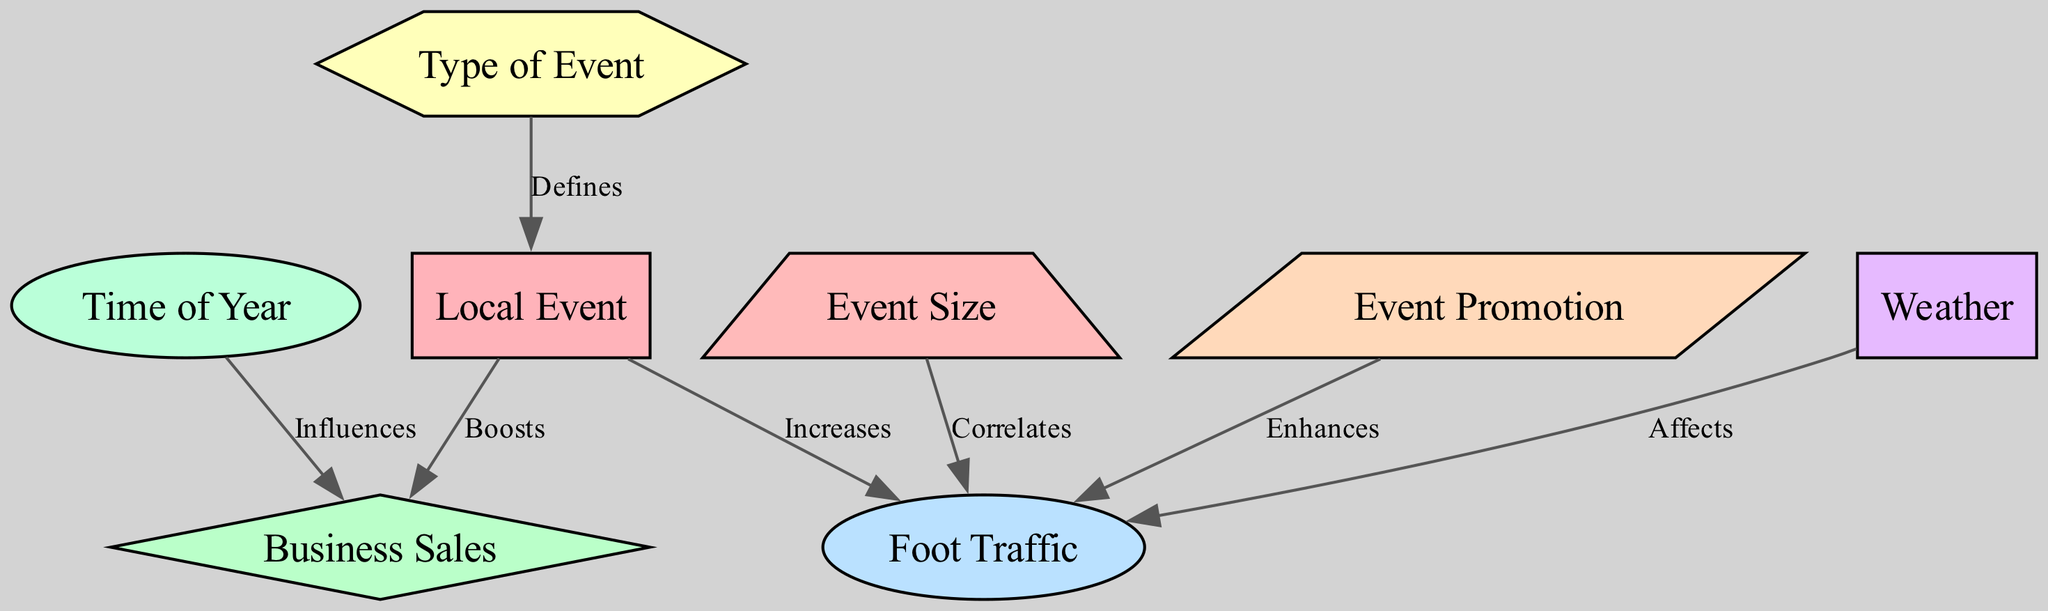What is the relationship between local events and foot traffic? The diagram shows that local events "Increases" foot traffic, indicating that when a local event occurs, there tends to be more people visiting the area, likely due to the event attracting attendees.
Answer: Increases How many nodes are present in the diagram? Counting the nodes listed, there are eight distinct nodes representing entities or concepts related to the social science aspect of the diagram.
Answer: Eight What type of event influences business sales? Referring to the diagram, it indicates that "Time of Year" influences business sales, meaning that different times in the year might lead to varied sales outcomes for businesses.
Answer: Time of Year What effect does event promotion have on foot traffic? The diagram states that event promotion "Enhances" foot traffic, suggesting that effective advertising or promotion of events contributes positively to the number of visitors attending.
Answer: Enhances What correlates with foot traffic? According to the diagram, "Event Size" correlates with foot traffic, meaning that larger events may attract more people, thereby increasing foot traffic levels.
Answer: Event Size Which factor affects foot traffic? The diagram illustrates that "Weather" affects foot traffic, indicating that different weather conditions can influence how many people visit an area, especially during events.
Answer: Weather What defines the type of event? From the diagram, it is evident that the "Type of Event" is defined by the local event. This indicates that the nature of the local event determines the categorization or characteristics of that event.
Answer: Defines Does weather impact business sales directly? The diagram does not show a direct effect of weather on business sales; it specifically shows weather affecting foot traffic, but not business sales directly.
Answer: No 